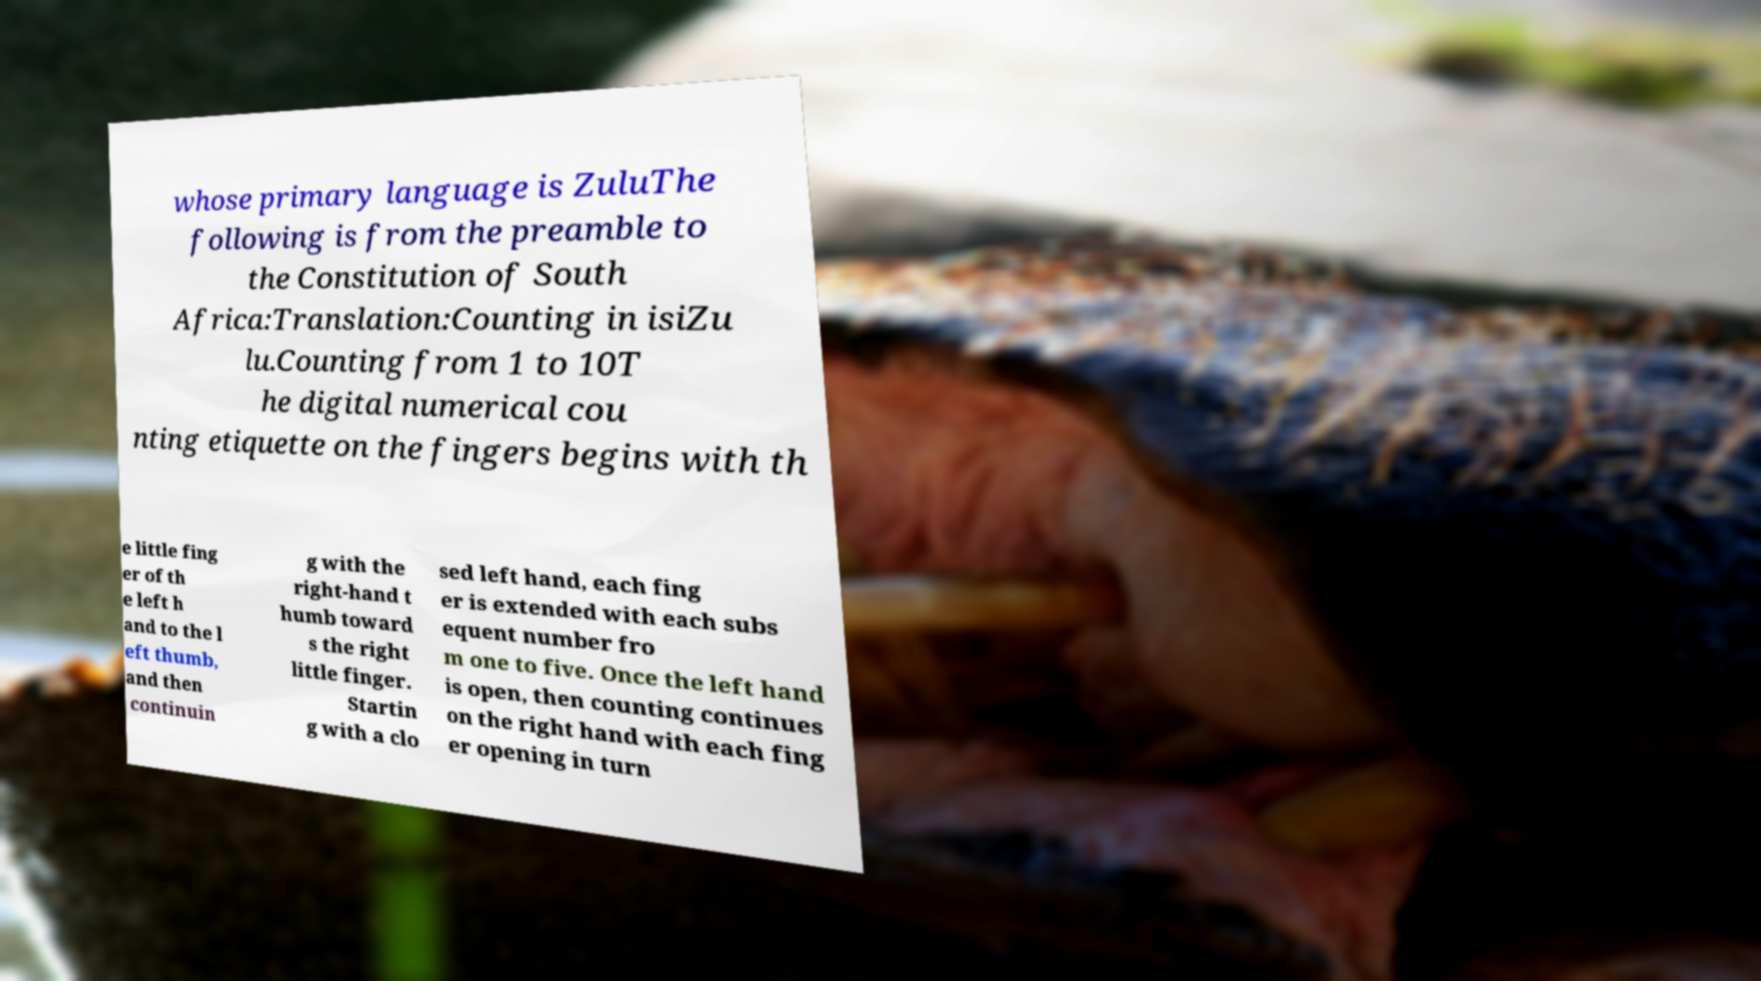Could you extract and type out the text from this image? whose primary language is ZuluThe following is from the preamble to the Constitution of South Africa:Translation:Counting in isiZu lu.Counting from 1 to 10T he digital numerical cou nting etiquette on the fingers begins with th e little fing er of th e left h and to the l eft thumb, and then continuin g with the right-hand t humb toward s the right little finger. Startin g with a clo sed left hand, each fing er is extended with each subs equent number fro m one to five. Once the left hand is open, then counting continues on the right hand with each fing er opening in turn 